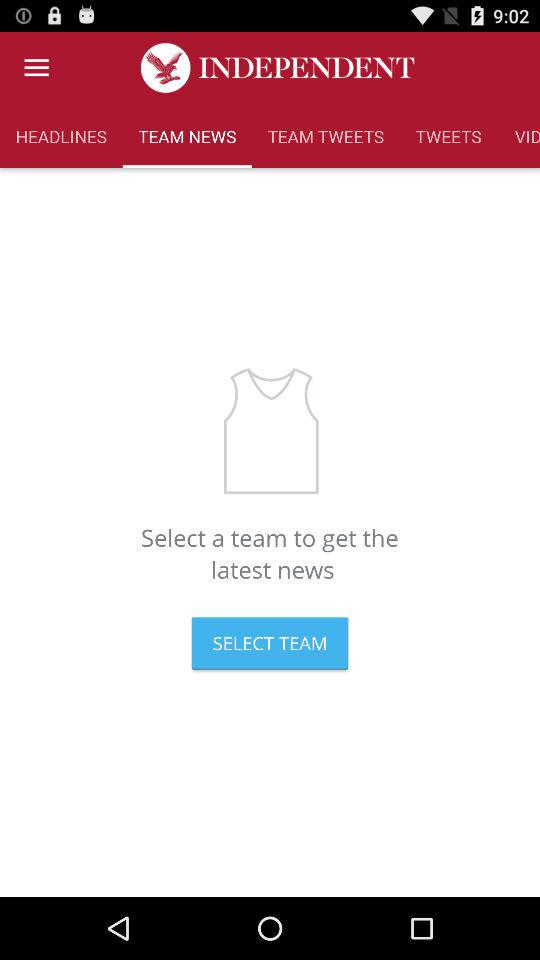Which option are we currently on? You are currently on the "TEAM NEWS" option. 